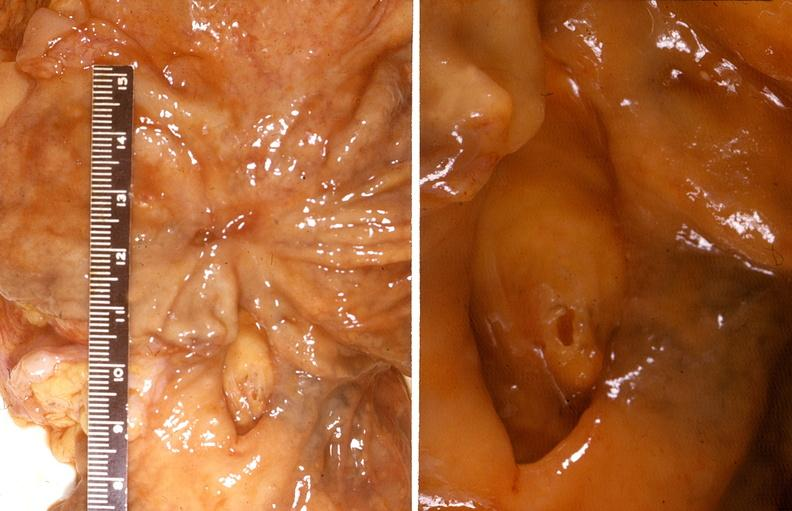s gastrointestinal present?
Answer the question using a single word or phrase. Yes 